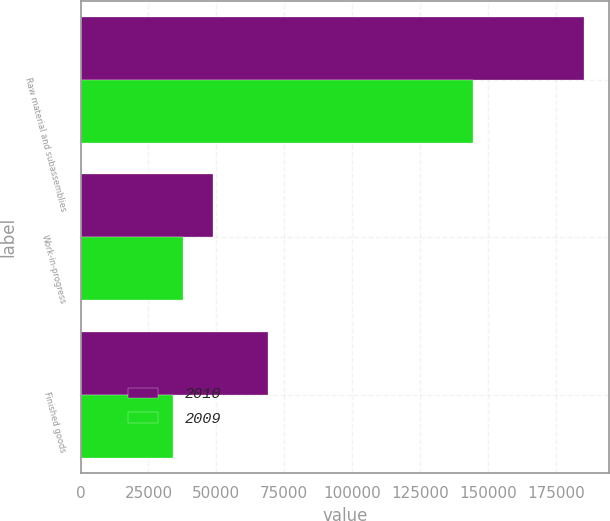<chart> <loc_0><loc_0><loc_500><loc_500><stacked_bar_chart><ecel><fcel>Raw material and subassemblies<fcel>Work-in-progress<fcel>Finished goods<nl><fcel>2010<fcel>185359<fcel>48788<fcel>69009<nl><fcel>2009<fcel>144555<fcel>37732<fcel>34213<nl></chart> 